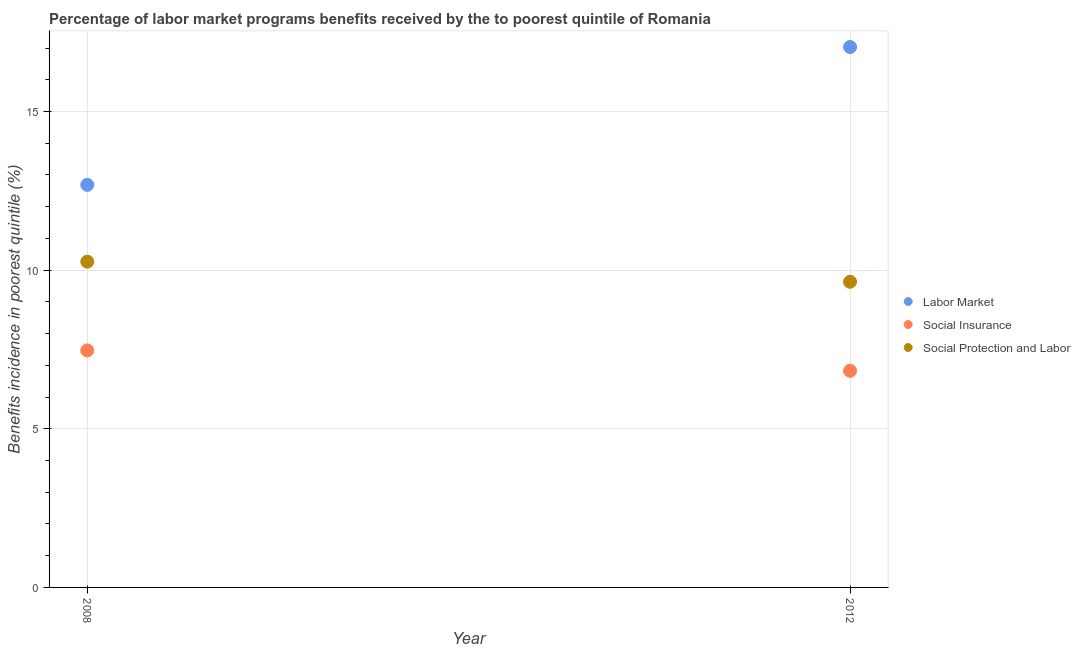How many different coloured dotlines are there?
Offer a terse response. 3. Is the number of dotlines equal to the number of legend labels?
Keep it short and to the point. Yes. What is the percentage of benefits received due to social protection programs in 2008?
Keep it short and to the point. 10.27. Across all years, what is the maximum percentage of benefits received due to social insurance programs?
Offer a very short reply. 7.47. Across all years, what is the minimum percentage of benefits received due to social insurance programs?
Your answer should be very brief. 6.83. What is the total percentage of benefits received due to labor market programs in the graph?
Your answer should be very brief. 29.72. What is the difference between the percentage of benefits received due to social insurance programs in 2008 and that in 2012?
Make the answer very short. 0.64. What is the difference between the percentage of benefits received due to labor market programs in 2012 and the percentage of benefits received due to social insurance programs in 2008?
Ensure brevity in your answer.  9.56. What is the average percentage of benefits received due to labor market programs per year?
Your answer should be compact. 14.86. In the year 2012, what is the difference between the percentage of benefits received due to social insurance programs and percentage of benefits received due to social protection programs?
Provide a succinct answer. -2.81. In how many years, is the percentage of benefits received due to labor market programs greater than 8 %?
Keep it short and to the point. 2. What is the ratio of the percentage of benefits received due to social protection programs in 2008 to that in 2012?
Offer a terse response. 1.07. Is the percentage of benefits received due to social insurance programs in 2008 less than that in 2012?
Provide a succinct answer. No. In how many years, is the percentage of benefits received due to social insurance programs greater than the average percentage of benefits received due to social insurance programs taken over all years?
Your answer should be compact. 1. Is it the case that in every year, the sum of the percentage of benefits received due to labor market programs and percentage of benefits received due to social insurance programs is greater than the percentage of benefits received due to social protection programs?
Your response must be concise. Yes. Does the percentage of benefits received due to social insurance programs monotonically increase over the years?
Offer a very short reply. No. Is the percentage of benefits received due to social protection programs strictly greater than the percentage of benefits received due to labor market programs over the years?
Your answer should be very brief. No. Is the percentage of benefits received due to social insurance programs strictly less than the percentage of benefits received due to social protection programs over the years?
Provide a succinct answer. Yes. What is the difference between two consecutive major ticks on the Y-axis?
Ensure brevity in your answer.  5. Are the values on the major ticks of Y-axis written in scientific E-notation?
Your answer should be very brief. No. Does the graph contain any zero values?
Your answer should be very brief. No. How many legend labels are there?
Make the answer very short. 3. How are the legend labels stacked?
Your answer should be very brief. Vertical. What is the title of the graph?
Your answer should be very brief. Percentage of labor market programs benefits received by the to poorest quintile of Romania. Does "Coal" appear as one of the legend labels in the graph?
Your answer should be compact. No. What is the label or title of the X-axis?
Your answer should be very brief. Year. What is the label or title of the Y-axis?
Provide a short and direct response. Benefits incidence in poorest quintile (%). What is the Benefits incidence in poorest quintile (%) in Labor Market in 2008?
Offer a terse response. 12.69. What is the Benefits incidence in poorest quintile (%) in Social Insurance in 2008?
Ensure brevity in your answer.  7.47. What is the Benefits incidence in poorest quintile (%) of Social Protection and Labor in 2008?
Ensure brevity in your answer.  10.27. What is the Benefits incidence in poorest quintile (%) of Labor Market in 2012?
Your response must be concise. 17.03. What is the Benefits incidence in poorest quintile (%) of Social Insurance in 2012?
Keep it short and to the point. 6.83. What is the Benefits incidence in poorest quintile (%) in Social Protection and Labor in 2012?
Offer a terse response. 9.63. Across all years, what is the maximum Benefits incidence in poorest quintile (%) in Labor Market?
Offer a very short reply. 17.03. Across all years, what is the maximum Benefits incidence in poorest quintile (%) in Social Insurance?
Make the answer very short. 7.47. Across all years, what is the maximum Benefits incidence in poorest quintile (%) of Social Protection and Labor?
Your answer should be compact. 10.27. Across all years, what is the minimum Benefits incidence in poorest quintile (%) of Labor Market?
Offer a very short reply. 12.69. Across all years, what is the minimum Benefits incidence in poorest quintile (%) in Social Insurance?
Your answer should be very brief. 6.83. Across all years, what is the minimum Benefits incidence in poorest quintile (%) in Social Protection and Labor?
Keep it short and to the point. 9.63. What is the total Benefits incidence in poorest quintile (%) in Labor Market in the graph?
Provide a short and direct response. 29.72. What is the total Benefits incidence in poorest quintile (%) of Social Insurance in the graph?
Ensure brevity in your answer.  14.3. What is the total Benefits incidence in poorest quintile (%) in Social Protection and Labor in the graph?
Keep it short and to the point. 19.9. What is the difference between the Benefits incidence in poorest quintile (%) in Labor Market in 2008 and that in 2012?
Your answer should be compact. -4.35. What is the difference between the Benefits incidence in poorest quintile (%) of Social Insurance in 2008 and that in 2012?
Keep it short and to the point. 0.64. What is the difference between the Benefits incidence in poorest quintile (%) in Social Protection and Labor in 2008 and that in 2012?
Your response must be concise. 0.63. What is the difference between the Benefits incidence in poorest quintile (%) of Labor Market in 2008 and the Benefits incidence in poorest quintile (%) of Social Insurance in 2012?
Make the answer very short. 5.86. What is the difference between the Benefits incidence in poorest quintile (%) in Labor Market in 2008 and the Benefits incidence in poorest quintile (%) in Social Protection and Labor in 2012?
Offer a terse response. 3.05. What is the difference between the Benefits incidence in poorest quintile (%) in Social Insurance in 2008 and the Benefits incidence in poorest quintile (%) in Social Protection and Labor in 2012?
Offer a very short reply. -2.16. What is the average Benefits incidence in poorest quintile (%) of Labor Market per year?
Make the answer very short. 14.86. What is the average Benefits incidence in poorest quintile (%) in Social Insurance per year?
Keep it short and to the point. 7.15. What is the average Benefits incidence in poorest quintile (%) in Social Protection and Labor per year?
Provide a succinct answer. 9.95. In the year 2008, what is the difference between the Benefits incidence in poorest quintile (%) in Labor Market and Benefits incidence in poorest quintile (%) in Social Insurance?
Your answer should be very brief. 5.22. In the year 2008, what is the difference between the Benefits incidence in poorest quintile (%) of Labor Market and Benefits incidence in poorest quintile (%) of Social Protection and Labor?
Your answer should be compact. 2.42. In the year 2008, what is the difference between the Benefits incidence in poorest quintile (%) of Social Insurance and Benefits incidence in poorest quintile (%) of Social Protection and Labor?
Ensure brevity in your answer.  -2.8. In the year 2012, what is the difference between the Benefits incidence in poorest quintile (%) in Labor Market and Benefits incidence in poorest quintile (%) in Social Insurance?
Make the answer very short. 10.2. In the year 2012, what is the difference between the Benefits incidence in poorest quintile (%) in Labor Market and Benefits incidence in poorest quintile (%) in Social Protection and Labor?
Provide a succinct answer. 7.4. In the year 2012, what is the difference between the Benefits incidence in poorest quintile (%) of Social Insurance and Benefits incidence in poorest quintile (%) of Social Protection and Labor?
Your answer should be very brief. -2.81. What is the ratio of the Benefits incidence in poorest quintile (%) in Labor Market in 2008 to that in 2012?
Provide a succinct answer. 0.74. What is the ratio of the Benefits incidence in poorest quintile (%) in Social Insurance in 2008 to that in 2012?
Provide a short and direct response. 1.09. What is the ratio of the Benefits incidence in poorest quintile (%) in Social Protection and Labor in 2008 to that in 2012?
Offer a terse response. 1.07. What is the difference between the highest and the second highest Benefits incidence in poorest quintile (%) in Labor Market?
Offer a very short reply. 4.35. What is the difference between the highest and the second highest Benefits incidence in poorest quintile (%) of Social Insurance?
Ensure brevity in your answer.  0.64. What is the difference between the highest and the second highest Benefits incidence in poorest quintile (%) in Social Protection and Labor?
Provide a succinct answer. 0.63. What is the difference between the highest and the lowest Benefits incidence in poorest quintile (%) of Labor Market?
Ensure brevity in your answer.  4.35. What is the difference between the highest and the lowest Benefits incidence in poorest quintile (%) in Social Insurance?
Offer a very short reply. 0.64. What is the difference between the highest and the lowest Benefits incidence in poorest quintile (%) in Social Protection and Labor?
Offer a very short reply. 0.63. 